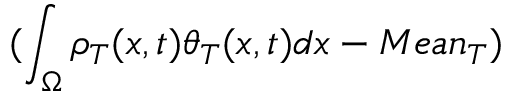<formula> <loc_0><loc_0><loc_500><loc_500>( \int _ { \Omega } \rho _ { T } ( x , t ) \theta _ { T } ( x , t ) d x - M e a n _ { T } )</formula> 